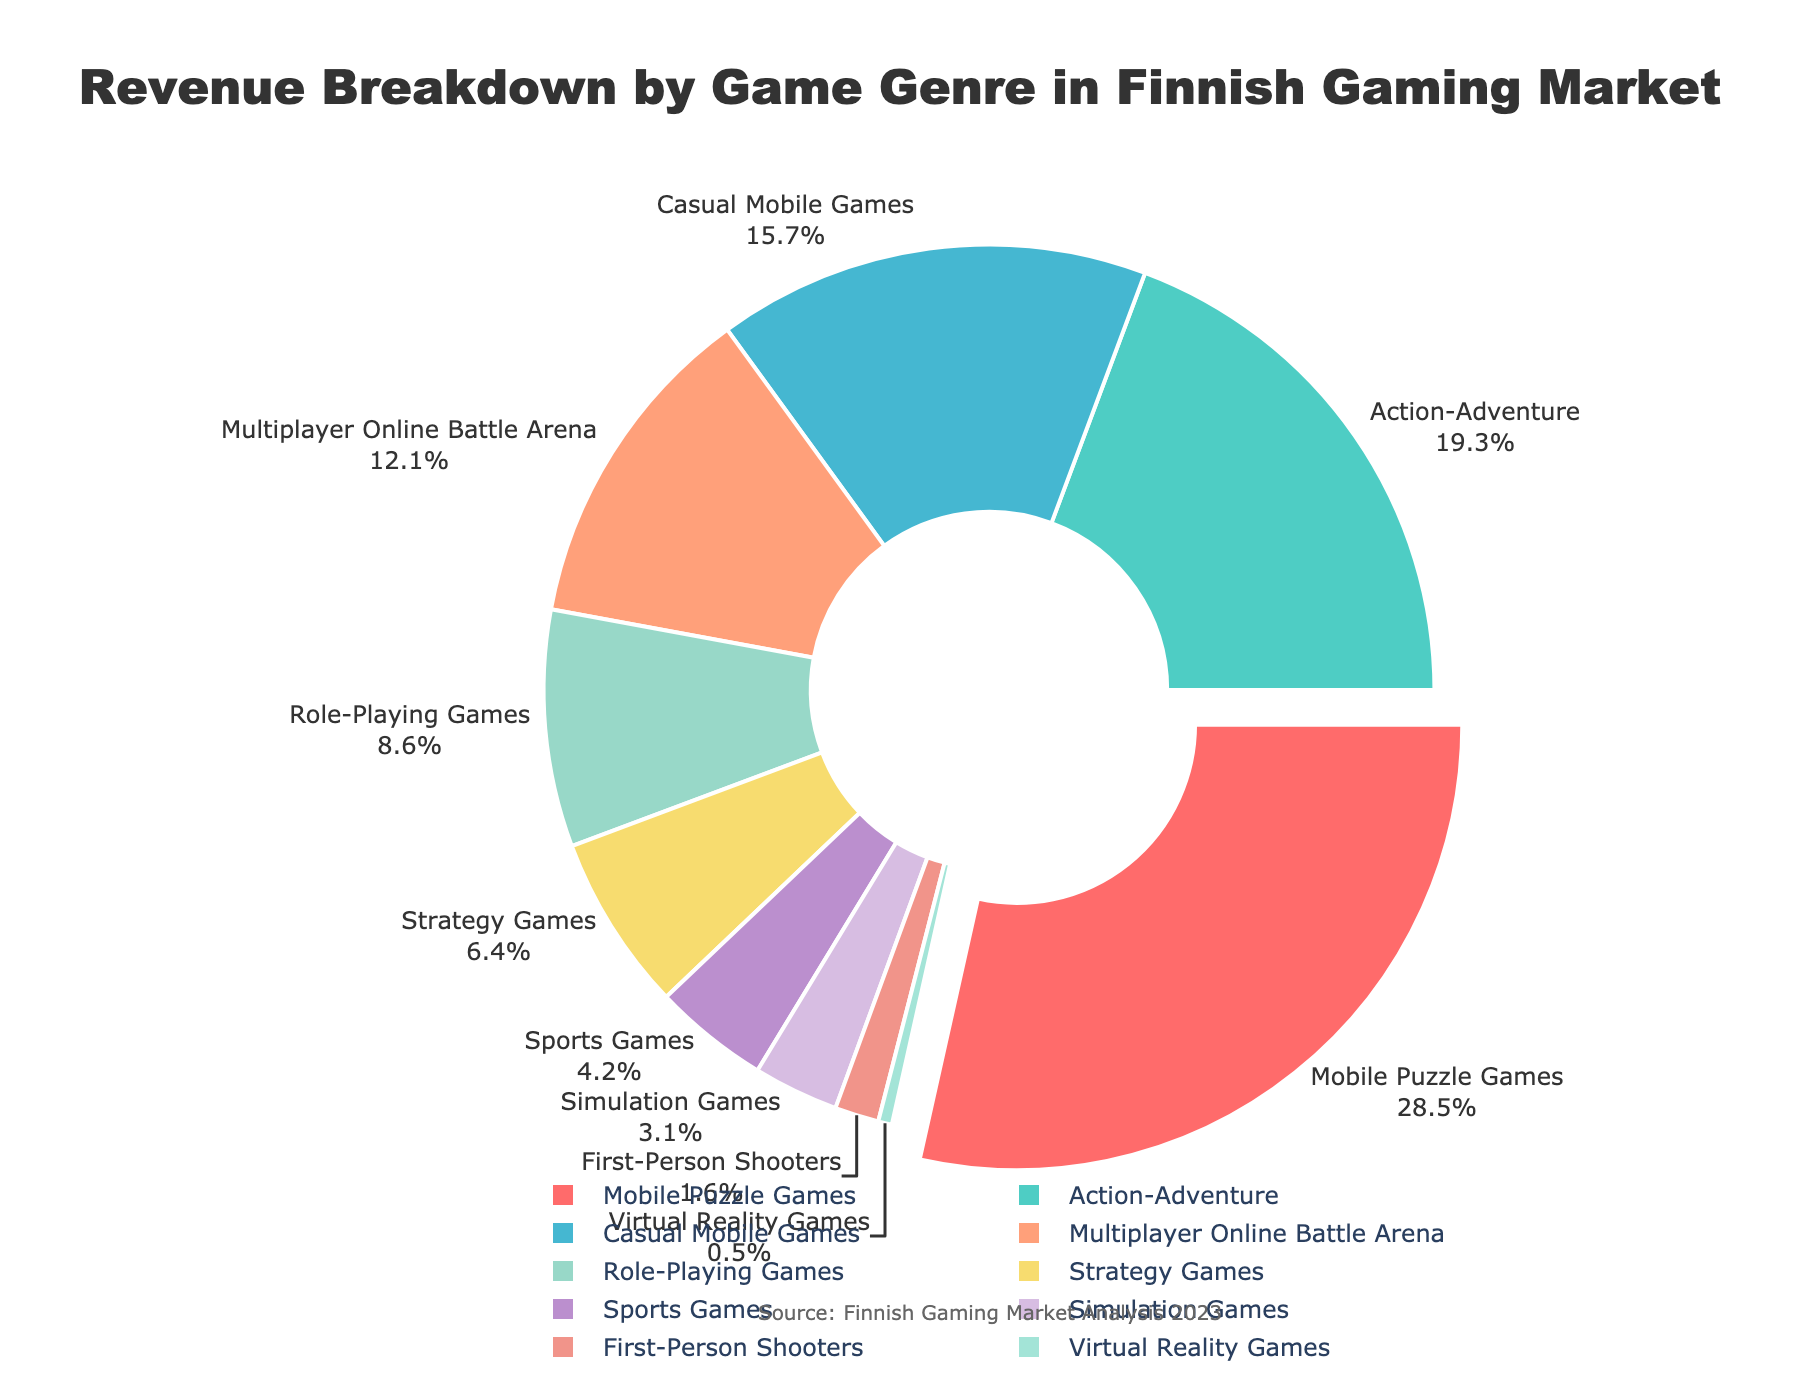What genre contributes the highest percentage of revenue? The pie chart shows that "Mobile Puzzle Games" has the largest portion highlighted by the slice pulled out slightly. This corresponds to the data giving Mobile Puzzle Games a 28.5% revenue share.
Answer: Mobile Puzzle Games Which genre has the second-lowest revenue percentage, and what is it? To find the second-lowest, order the genres by revenue percentage. The lowest is "Virtual Reality Games" at 0.5%, and the second-lowest is "First-Person Shooters" at 1.6%.
Answer: First-Person Shooters, 1.6% Which genres together contribute more than 50% of the revenue? Summing up the percentages starting from the highest until the total exceeds 50%: Mobile Puzzle Games (28.5%) + Action-Adventure (19.3%) = 47.8% + Casual Mobile Games (15.7%) = 63.5%. Thus, Mobile Puzzle Games, Action-Adventure, and Casual Mobile Games together contribute more than 50%.
Answer: Mobile Puzzle Games, Action-Adventure, Casual Mobile Games How much more revenue does "Action-Adventure" generate compared to "Strategy Games"? The "Action-Adventure" genre generates 19.3%, and "Strategy Games" generate 6.4%. The difference is 19.3% - 6.4% = 12.9%.
Answer: 12.9% What percentage of revenue is generated by genres that fall under 10% each? Identify and sum the genres with under 10% revenue: Role-Playing Games (8.6%) + Strategy Games (6.4%) + Sports Games (4.2%) + Simulation Games (3.1%) + First-Person Shooters (1.6%) + Virtual Reality Games (0.5%) = 24.4%.
Answer: 24.4% How many genres contribute less than 5% of the revenue each? From the pie chart, identify genres with less than 5% revenue: Sports Games (4.2%), Simulation Games (3.1%), First-Person Shooters (1.6%), Virtual Reality Games (0.5%). There are 4 genres.
Answer: 4 Which genre's slice is highlighted in the pie chart, and why? The slice for "Mobile Puzzle Games" is slightly pulled out, highlighting it as it has the highest revenue contribution at 28.5%.
Answer: Mobile Puzzle Games What's the combined revenue percentage of "Multiplayer Online Battle Arena" and "Role-Playing Games"? "Multiplayer Online Battle Arena" has 12.1%, and "Role-Playing Games" has 8.6%. The combined is 12.1% + 8.6% = 20.7%.
Answer: 20.7% Compare the revenue of "Casual Mobile Games" and "Strategy Games." Which is greater? "Casual Mobile Games" generate 15.7%, while "Strategy Games" generate 6.4%. "Casual Mobile Games" have a higher revenue percentage.
Answer: Casual Mobile Games 